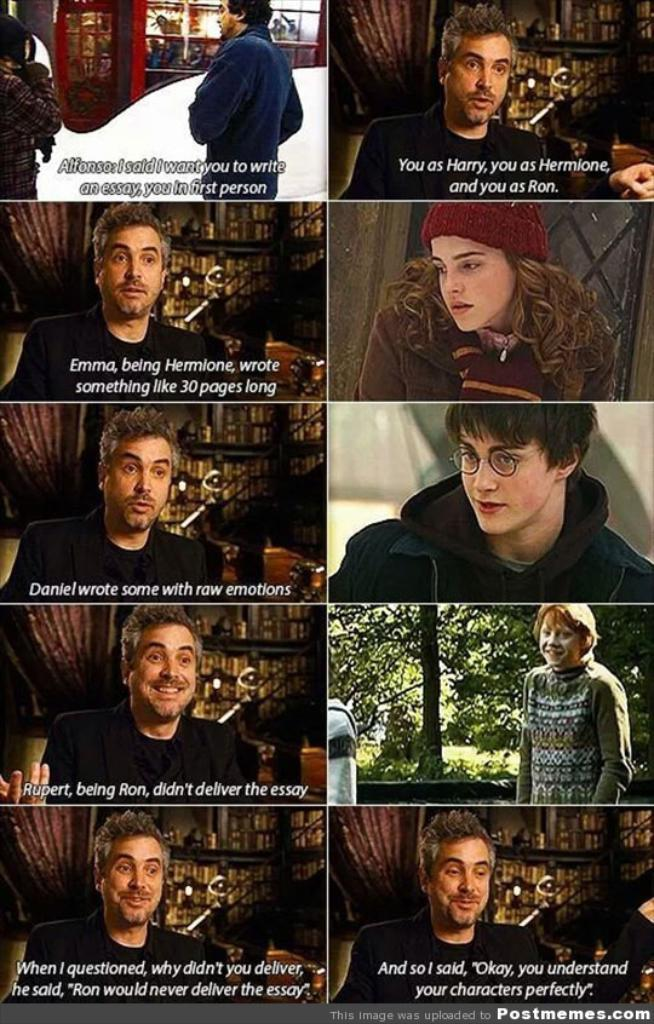Can you describe the setting or environment in the image? Unfortunately, there are no specific facts provided about the image, so it is impossible to describe the setting or environment. Reasoning: Since there are no specific facts provided about the image, we cannot create a conversation based on the details of the image. Therefore, we acknowledge the lack of information and politely decline to answer any questions about the image. Absurd Question/Answer: How many caves can be seen in the image? There are no caves present in the image, as there is no information provided about the image. How many planes are flying over the gate in the image? There is no information provided about the image, so it is impossible to determine if there are any planes or gates present. 